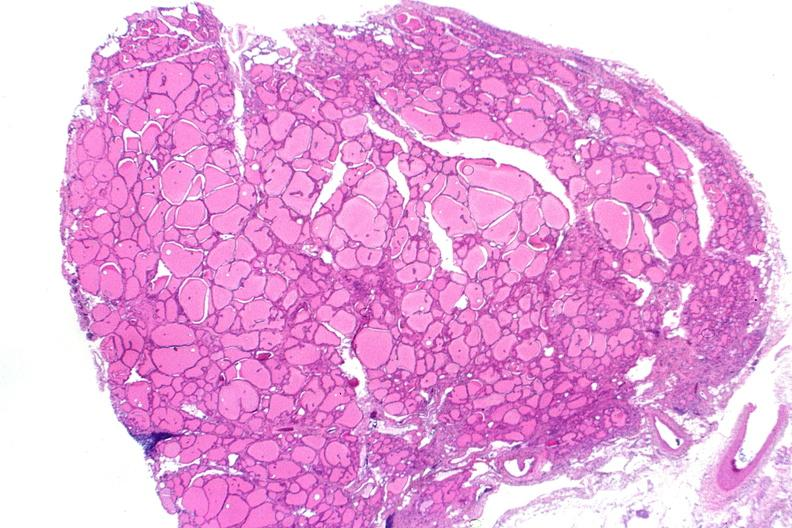s pus in test tube present?
Answer the question using a single word or phrase. No 